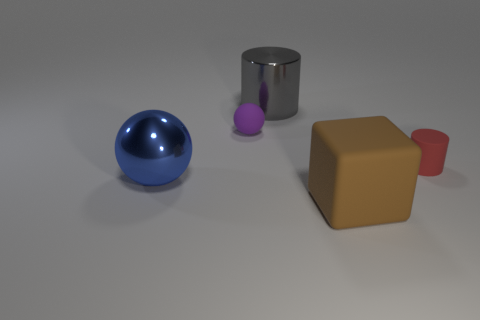Is the large blue metallic object the same shape as the gray thing?
Keep it short and to the point. No. What number of other objects are there of the same size as the red thing?
Offer a terse response. 1. What color is the rubber cylinder?
Your response must be concise. Red. How many large objects are cyan rubber objects or metal spheres?
Make the answer very short. 1. There is a object that is right of the big matte cube; is it the same size as the matte thing that is to the left of the gray cylinder?
Your answer should be very brief. Yes. There is a gray shiny object that is the same shape as the small red matte thing; what is its size?
Make the answer very short. Large. Are there more small spheres that are on the right side of the purple matte thing than matte cylinders in front of the big cube?
Provide a short and direct response. No. What is the thing that is both to the left of the big cylinder and in front of the small purple object made of?
Make the answer very short. Metal. The other large thing that is the same shape as the red matte object is what color?
Your answer should be very brief. Gray. What is the size of the rubber sphere?
Provide a succinct answer. Small. 